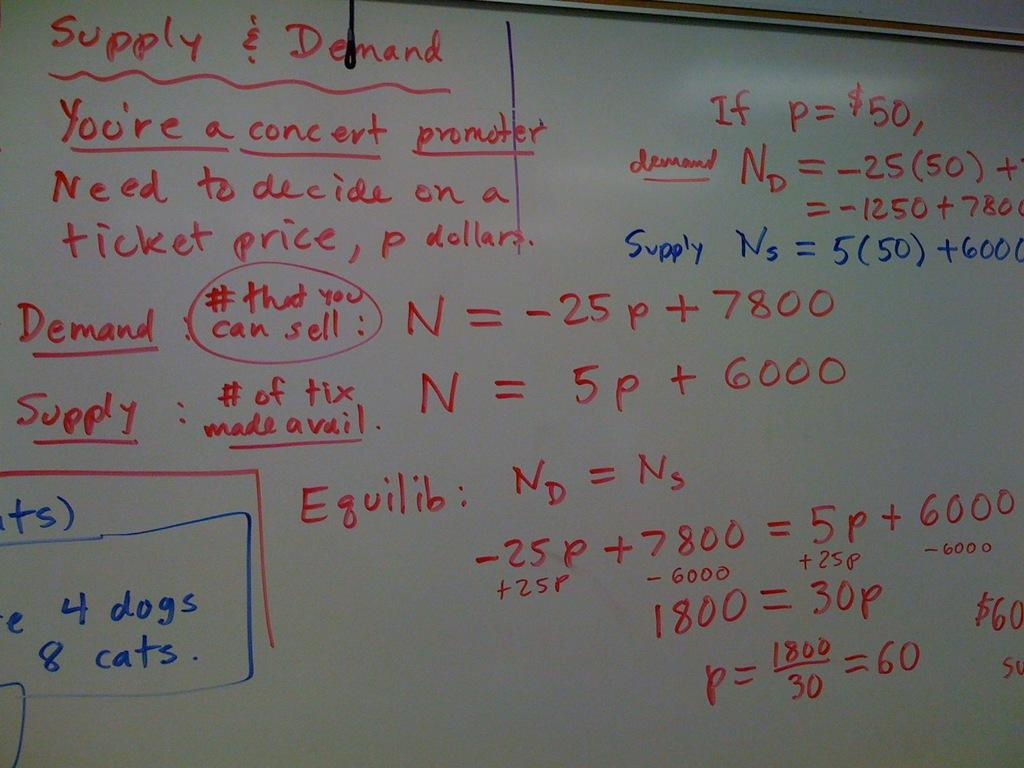What is the main object in the image? There is a board in the image. What can be seen on the board? Texts are written on the board. What colors are used to write the texts on the board? The texts are written with red and blue sketch. How many sheep are visible in the image? There are no sheep present in the image. What type of curve can be seen in the image? There is no curve visible in the image; it features a board with texts written on it. 